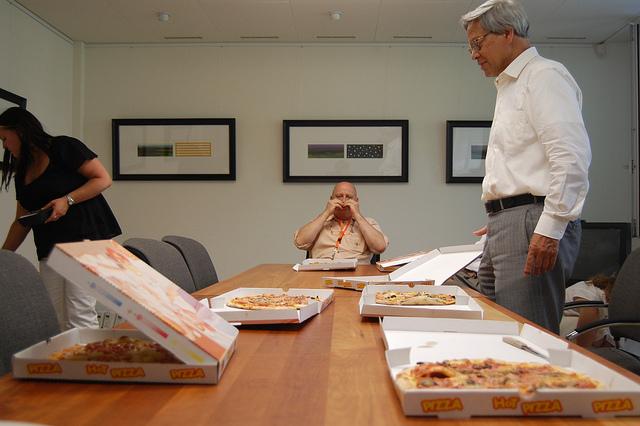What is in the box?
Quick response, please. Pizza. How many cakes are there?
Keep it brief. 0. How much care is being put into this food's preparation?
Keep it brief. None. Is this a restaurant?
Write a very short answer. No. What type of shirt is the male wearing?
Write a very short answer. Dress shirt. What color is the chair?
Give a very brief answer. Gray. Does the person have a mask on?
Write a very short answer. No. How many pizzas are there?
Keep it brief. 5. Is this a bakery?
Short answer required. No. What are the toothpicks in?
Concise answer only. Pizza. What room is this?
Quick response, please. Conference room. What kind of food is that?
Be succinct. Pizza. Where is he looking?
Quick response, please. Pizza. What color is the wall?
Be succinct. White. How many people are in the photo?
Short answer required. 3. Is this pizza?
Write a very short answer. Yes. Is everyone eating?
Answer briefly. No. Are her clothes patterned?
Quick response, please. No. 